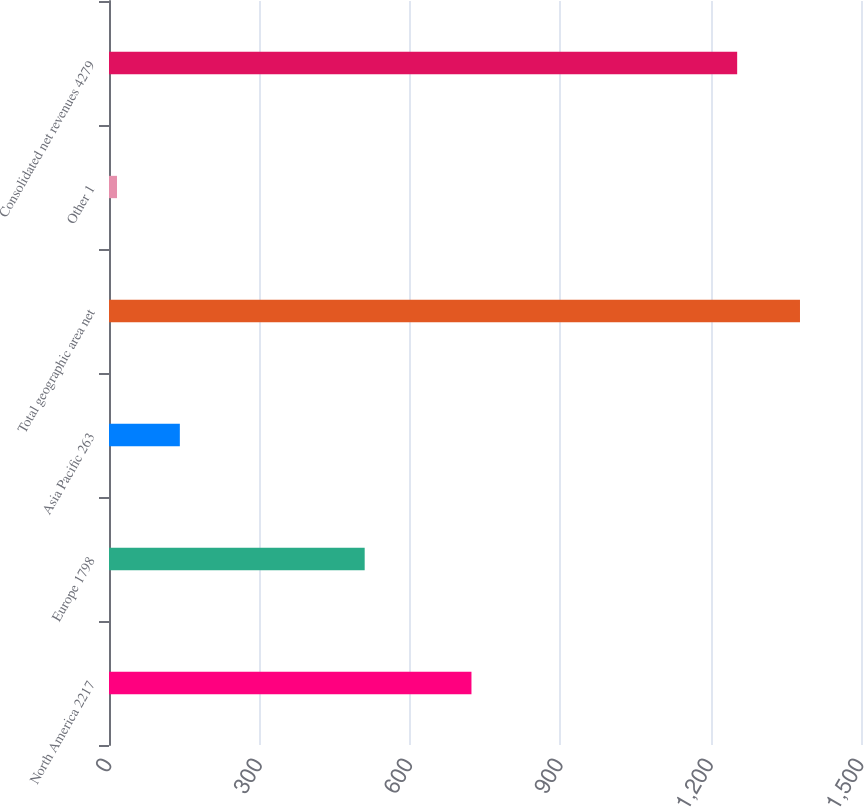Convert chart. <chart><loc_0><loc_0><loc_500><loc_500><bar_chart><fcel>North America 2217<fcel>Europe 1798<fcel>Asia Pacific 263<fcel>Total geographic area net<fcel>Other 1<fcel>Consolidated net revenues 4279<nl><fcel>723<fcel>510<fcel>141.3<fcel>1378.3<fcel>16<fcel>1253<nl></chart> 